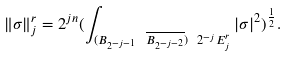<formula> <loc_0><loc_0><loc_500><loc_500>\| \sigma \| ^ { r } _ { j } = 2 ^ { j n } ( \int _ { ( B _ { 2 ^ { - j - 1 } } \ \overline { B _ { 2 ^ { - j - 2 } } } ) \ 2 ^ { - j } E ^ { r } _ { j } } | \sigma | ^ { 2 } ) ^ { \frac { 1 } { 2 } } .</formula> 